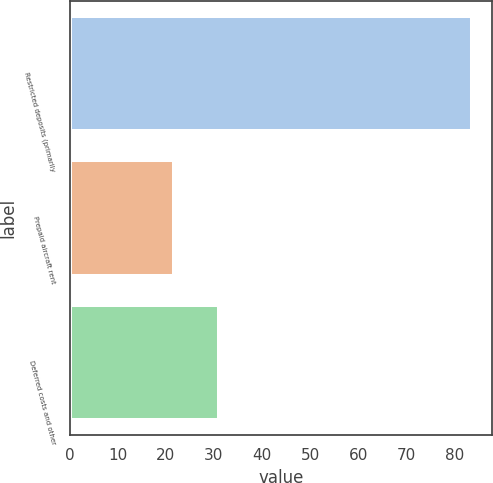Convert chart. <chart><loc_0><loc_0><loc_500><loc_500><bar_chart><fcel>Restricted deposits (primarily<fcel>Prepaid aircraft rent<fcel>Deferred costs and other<nl><fcel>83.6<fcel>21.6<fcel>31.1<nl></chart> 